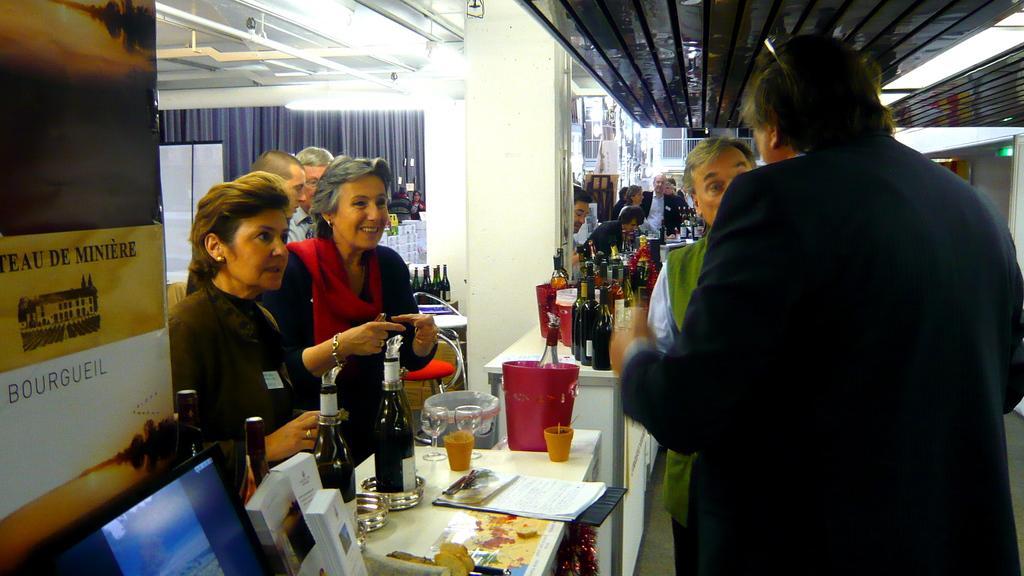Can you describe this image briefly? This image consist of tables alcohol bottles, glasses and people. People are standing near tables. There is a curtain on the backside. There are the lights on the top. 